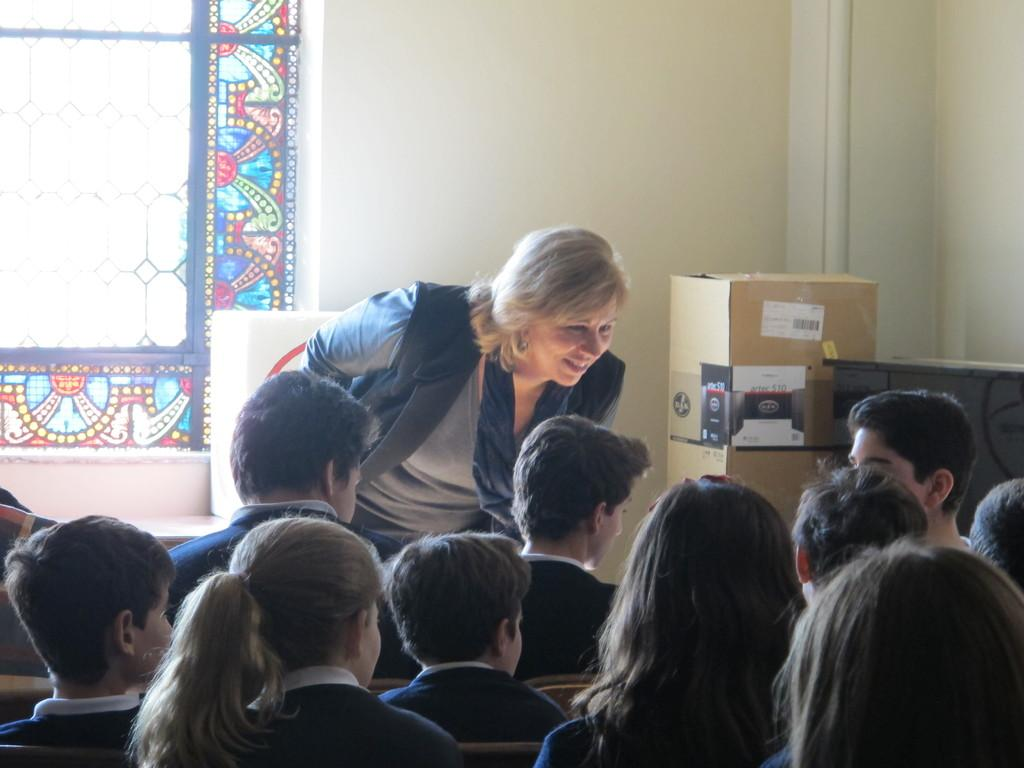What are the people in the image doing? The people in the image are sitting. Is there anyone standing in the image? Yes, there is a person standing in the image. What objects can be seen in the image? There are boxes in the image. What can be seen in the background of the image? There is a wall with a window in the background of the image. Can you tell me how many rats are visible in the image? There are no rats present in the image. What type of pickle is being used as a prop in the image? There is no pickle present in the image. 